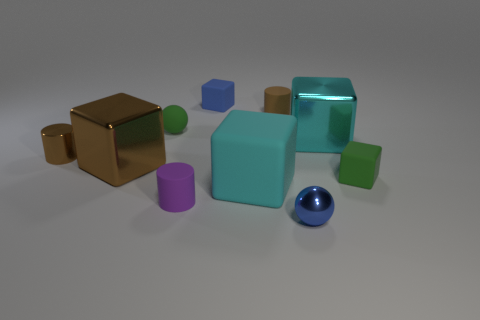How many other things are the same material as the small green cube?
Your answer should be compact. 5. The big block that is both on the left side of the small metallic ball and to the right of the tiny rubber sphere is what color?
Your response must be concise. Cyan. Is the cube left of the purple matte cylinder made of the same material as the brown thing right of the tiny blue matte block?
Your response must be concise. No. Is the size of the purple object to the left of the brown matte thing the same as the small brown metal thing?
Your answer should be compact. Yes. Does the matte ball have the same color as the large block right of the metal ball?
Ensure brevity in your answer.  No. There is a tiny matte object that is the same color as the metal cylinder; what is its shape?
Your answer should be very brief. Cylinder. The large brown metal thing has what shape?
Ensure brevity in your answer.  Cube. Is the color of the small shiny cylinder the same as the tiny metal ball?
Provide a short and direct response. No. How many things are blue objects that are in front of the blue rubber cube or big blue rubber cubes?
Ensure brevity in your answer.  1. There is a green cube that is the same material as the small blue block; what is its size?
Ensure brevity in your answer.  Small. 